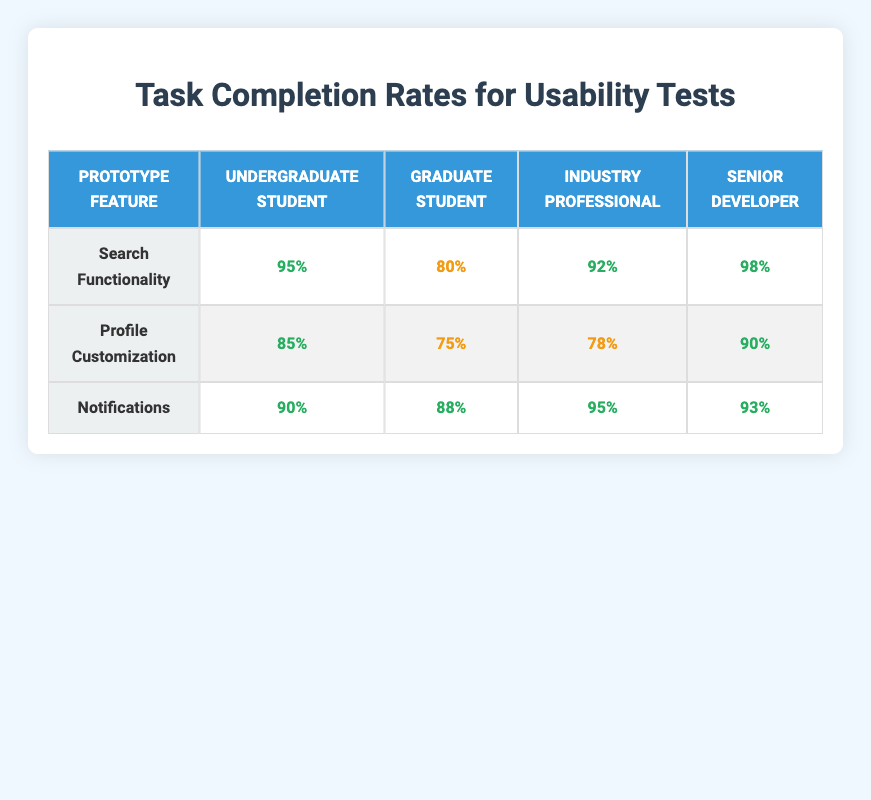What is the task completion rate for Undergraduate Students in Search Functionality? According to the table, the task completion rate for Undergraduate Students when testing the Search Functionality is 95%.
Answer: 95% What is the task completion rate for Graduate Students in Profile Customization? The table shows that the task completion rate for Graduate Students in Profile Customization is 75%.
Answer: 75% Which prototype feature has the highest task completion rate among Senior Developers? Referring to the table, the task completion rate for Senior Developers is highest for the Search Functionality, with a rate of 98%.
Answer: 98% What is the average task completion rate for Notifications across all tester backgrounds? The task completion rates for Notifications are: 90% (Undergraduate), 88% (Graduate), 95% (Industry Professional), and 93% (Senior Developer). The average is (90 + 88 + 95 + 93) / 4 = 91.5%.
Answer: 91.5% Did all tester backgrounds have a task completion rate of at least 80% for Profile Customization? Examining the table, we see the task completion rates for Profile Customization are 85% (Undergraduate), 75% (Graduate), 78% (Industry Professional), and 90% (Senior Developer). Since Graduate Students have a rate below 80%, the answer is no.
Answer: No Which tester background has the lowest task completion rate for Notifications? From the data in the table, the Graduate Students have the lowest task completion rate for Notifications at 88%.
Answer: 88% What is the difference in task completion rates for Search Functionality between Senior Developers and Graduate Students? The task completion rate for Senior Developers in Search Functionality is 98%, while for Graduate Students, it is 80%. The difference is 98% - 80% = 18%.
Answer: 18% Is the task completion rate for Industry Professionals in Notifications higher than that for Graduate Students in the same feature? The task completion rate for Industry Professionals in Notifications is 95%, while for Graduate Students, it is 88%. Since 95% is greater than 88%, the answer is yes.
Answer: Yes Which prototype feature do Undergraduate Students perform best in based on the task completion rates? According to the table, Undergraduate Students have the highest task completion rate in Search Functionality (95%), compared to 85% in Profile Customization and 90% in Notifications.
Answer: Search Functionality 